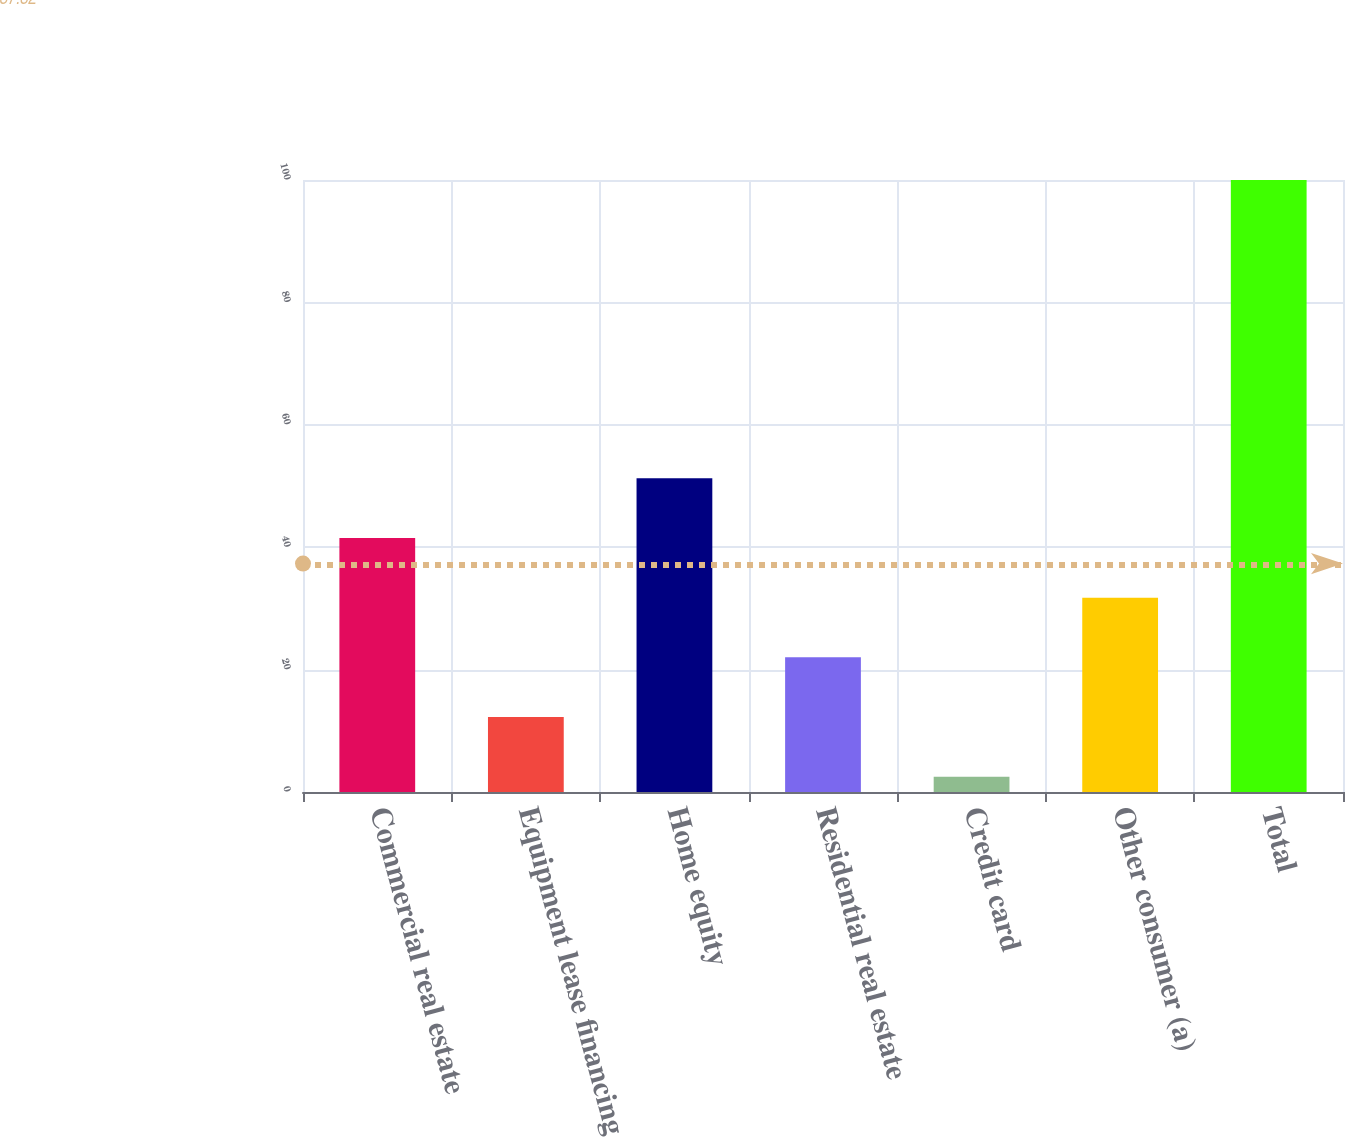Convert chart. <chart><loc_0><loc_0><loc_500><loc_500><bar_chart><fcel>Commercial real estate<fcel>Equipment lease financing<fcel>Home equity<fcel>Residential real estate<fcel>Credit card<fcel>Other consumer (a)<fcel>Total<nl><fcel>41.5<fcel>12.25<fcel>51.25<fcel>22<fcel>2.5<fcel>31.75<fcel>100<nl></chart> 